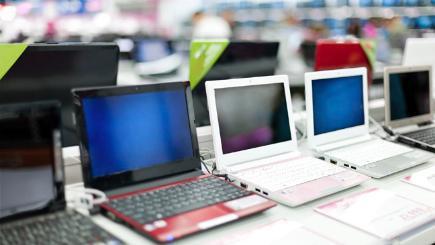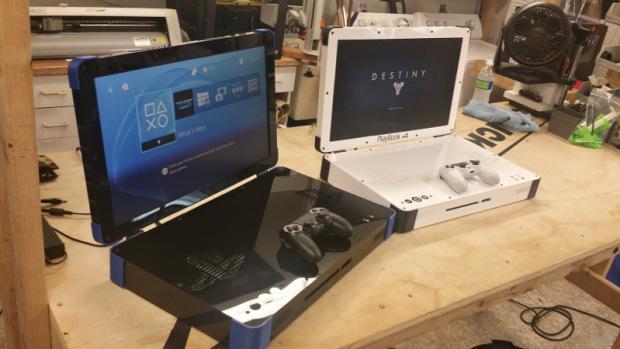The first image is the image on the left, the second image is the image on the right. For the images shown, is this caption "An image shows a row of at least three open laptops, with screens angled facing rightward." true? Answer yes or no. Yes. The first image is the image on the left, the second image is the image on the right. For the images displayed, is the sentence "At least one image contains a single laptop." factually correct? Answer yes or no. No. 